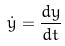<formula> <loc_0><loc_0><loc_500><loc_500>\dot { y } = \frac { d y } { d t }</formula> 